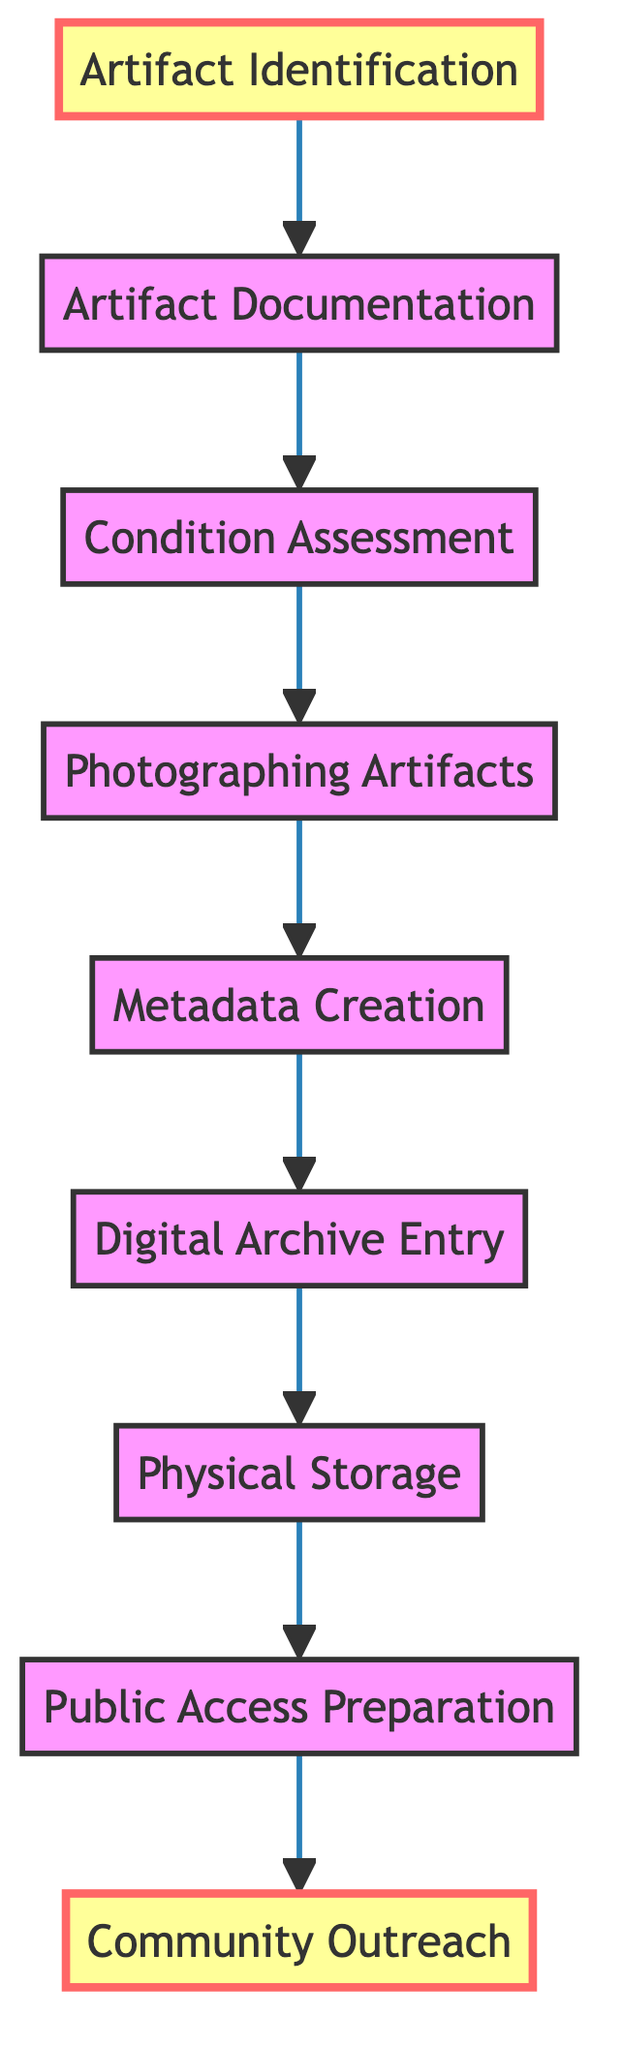What is the first step in the documentation flow? The first step in the documentation flow is "Artifact Identification," which is clearly indicated as the starting point of the diagram.
Answer: Artifact Identification How many nodes are present in the diagram? By counting each unique step or process in the diagram, there are a total of nine nodes: Artifact Identification, Artifact Documentation, Condition Assessment, Photographing Artifacts, Metadata Creation, Digital Archive Entry, Physical Storage, Public Access Preparation, and Community Outreach.
Answer: 9 What follows after "Photographing Artifacts"? Based on the sequence of flows in the diagram, "Metadata Creation" directly follows "Photographing Artifacts."
Answer: Metadata Creation Which step involves engaging with the Grapeland community? The last step in the documentation flow, which focuses on community engagement, is "Community Outreach." This is positioned at the top of the diagram.
Answer: Community Outreach If an artifact is documented, what is the next process? After "Artifact Documentation," the next step in the flowchart is "Condition Assessment," which means the physical condition of the documented artifacts is then evaluated.
Answer: Condition Assessment How does "Digital Archive Entry" relate to "Photographing Artifacts"? "Digital Archive Entry" follows "Metadata Creation," which is preceded by "Photographing Artifacts." Therefore, "Digital Archive Entry" is indirectly related to it as a subsequent step following photography and documentation processes.
Answer: Follows What is the last step in the flow? The last step in the flow of the documentation process is "Community Outreach," which signifies the conclusion of the archiving efforts and the engagement of the community.
Answer: Community Outreach Which step assesses the physical state of the artifacts? The step designated for assessing the artifacts’ physical condition is "Condition Assessment," which is specifically focused on noting any damages or required restorations.
Answer: Condition Assessment What process is involved before storing the artifacts physically? Prior to "Physical Storage," the step that takes place is "Digital Archive Entry," where the artifacts are entered into a digital system before their physical storage.
Answer: Digital Archive Entry 